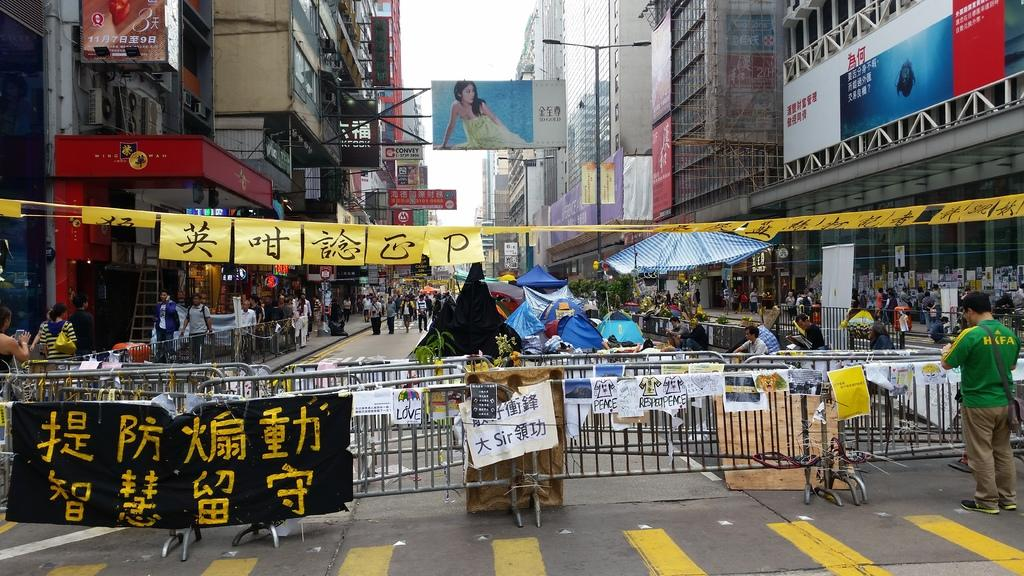<image>
Present a compact description of the photo's key features. Man standing by barrier gate with a green shirt with HKFA in yellow letters on the back. 